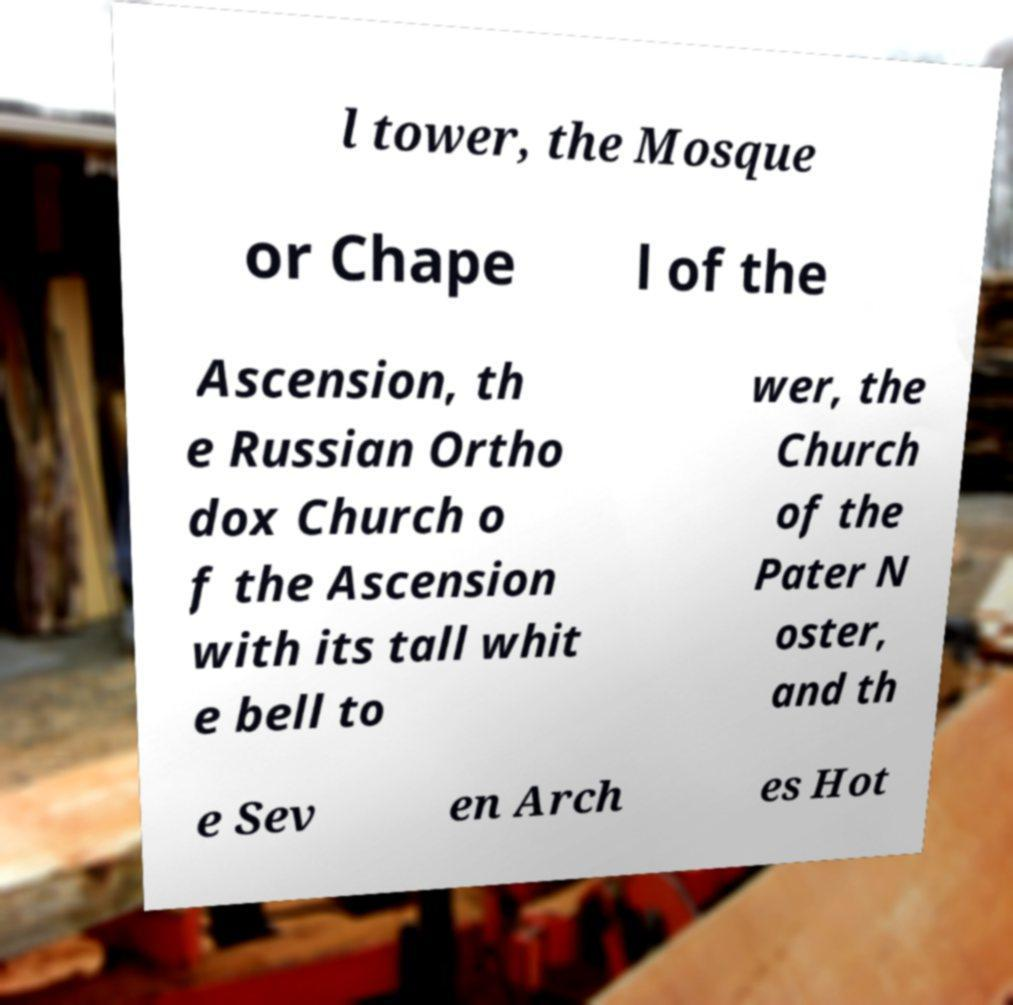Please identify and transcribe the text found in this image. l tower, the Mosque or Chape l of the Ascension, th e Russian Ortho dox Church o f the Ascension with its tall whit e bell to wer, the Church of the Pater N oster, and th e Sev en Arch es Hot 